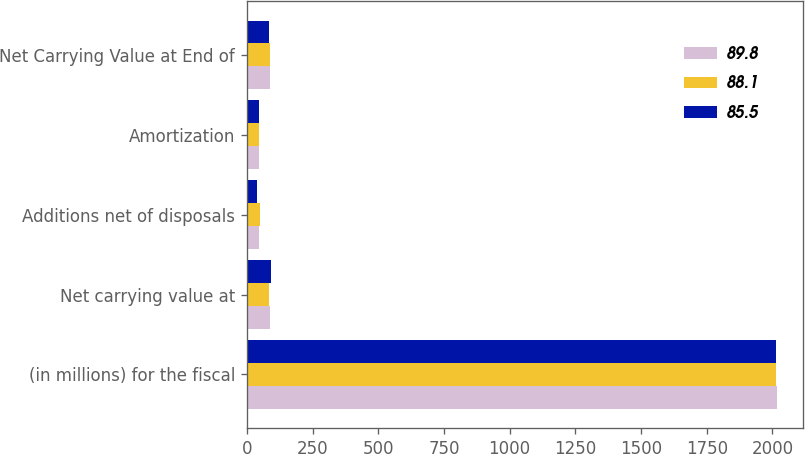Convert chart to OTSL. <chart><loc_0><loc_0><loc_500><loc_500><stacked_bar_chart><ecel><fcel>(in millions) for the fiscal<fcel>Net carrying value at<fcel>Additions net of disposals<fcel>Amortization<fcel>Net Carrying Value at End of<nl><fcel>89.8<fcel>2016<fcel>89.8<fcel>46.2<fcel>47.9<fcel>88.1<nl><fcel>88.1<fcel>2015<fcel>85.5<fcel>50.8<fcel>46.5<fcel>89.8<nl><fcel>85.5<fcel>2014<fcel>93.5<fcel>37.4<fcel>45.4<fcel>85.5<nl></chart> 